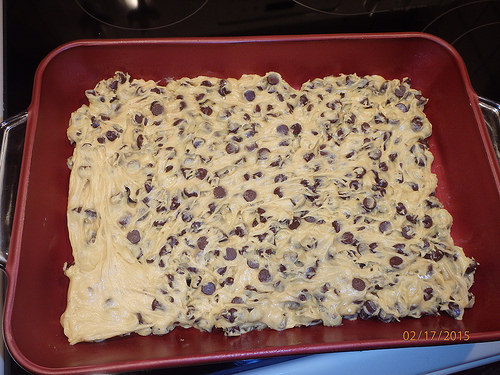<image>
Is there a chip next to the pan? No. The chip is not positioned next to the pan. They are located in different areas of the scene. 